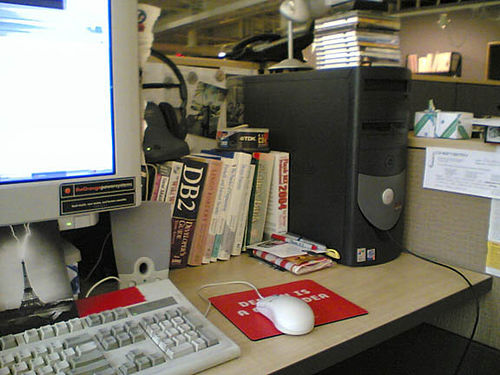<image>What landmark is pictured on the left? I am not sure. It can be the Eiffel Tower or the Mona Lisa. What landmark is pictured on the left? It can be seen that the Eiffel Tower is pictured on the left. 